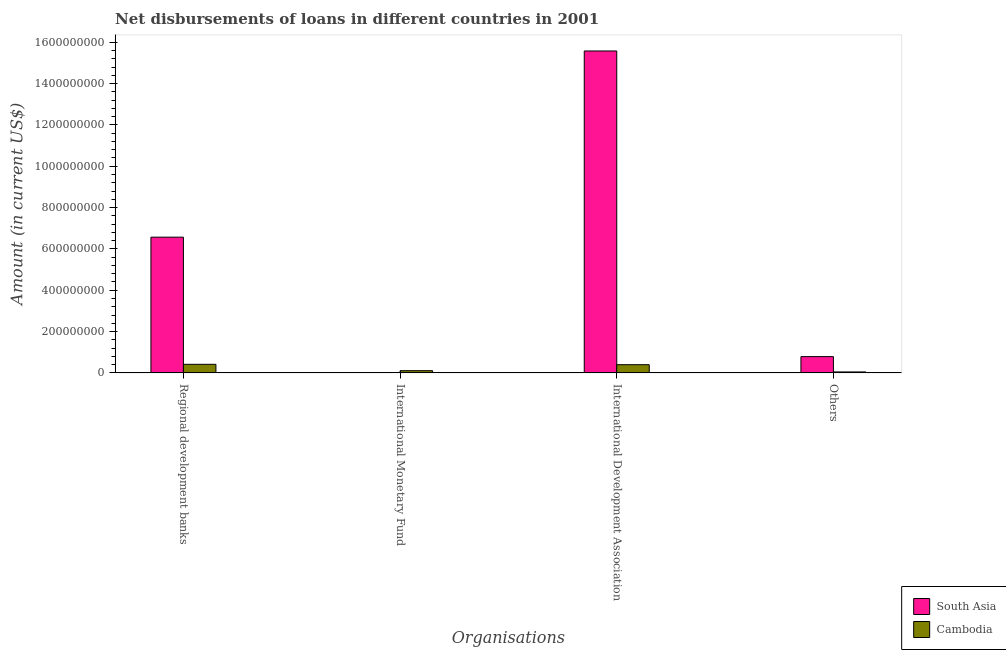Are the number of bars per tick equal to the number of legend labels?
Your response must be concise. No. How many bars are there on the 2nd tick from the right?
Provide a succinct answer. 2. What is the label of the 4th group of bars from the left?
Keep it short and to the point. Others. What is the amount of loan disimbursed by other organisations in Cambodia?
Your response must be concise. 4.50e+06. Across all countries, what is the maximum amount of loan disimbursed by international development association?
Offer a terse response. 1.56e+09. Across all countries, what is the minimum amount of loan disimbursed by other organisations?
Provide a succinct answer. 4.50e+06. What is the total amount of loan disimbursed by international development association in the graph?
Ensure brevity in your answer.  1.60e+09. What is the difference between the amount of loan disimbursed by other organisations in South Asia and that in Cambodia?
Your answer should be very brief. 7.42e+07. What is the difference between the amount of loan disimbursed by international monetary fund in Cambodia and the amount of loan disimbursed by other organisations in South Asia?
Your response must be concise. -6.81e+07. What is the average amount of loan disimbursed by international monetary fund per country?
Make the answer very short. 5.29e+06. What is the difference between the amount of loan disimbursed by regional development banks and amount of loan disimbursed by international development association in Cambodia?
Offer a terse response. 1.85e+06. What is the ratio of the amount of loan disimbursed by other organisations in Cambodia to that in South Asia?
Make the answer very short. 0.06. What is the difference between the highest and the second highest amount of loan disimbursed by other organisations?
Your response must be concise. 7.42e+07. What is the difference between the highest and the lowest amount of loan disimbursed by international development association?
Make the answer very short. 1.52e+09. Is the sum of the amount of loan disimbursed by other organisations in Cambodia and South Asia greater than the maximum amount of loan disimbursed by international monetary fund across all countries?
Offer a terse response. Yes. How many countries are there in the graph?
Offer a very short reply. 2. What is the difference between two consecutive major ticks on the Y-axis?
Make the answer very short. 2.00e+08. Does the graph contain any zero values?
Your response must be concise. Yes. Does the graph contain grids?
Provide a short and direct response. No. Where does the legend appear in the graph?
Ensure brevity in your answer.  Bottom right. How are the legend labels stacked?
Offer a terse response. Vertical. What is the title of the graph?
Offer a terse response. Net disbursements of loans in different countries in 2001. Does "Antigua and Barbuda" appear as one of the legend labels in the graph?
Your response must be concise. No. What is the label or title of the X-axis?
Give a very brief answer. Organisations. What is the label or title of the Y-axis?
Provide a short and direct response. Amount (in current US$). What is the Amount (in current US$) in South Asia in Regional development banks?
Your response must be concise. 6.57e+08. What is the Amount (in current US$) of Cambodia in Regional development banks?
Your response must be concise. 4.14e+07. What is the Amount (in current US$) in Cambodia in International Monetary Fund?
Your response must be concise. 1.06e+07. What is the Amount (in current US$) in South Asia in International Development Association?
Make the answer very short. 1.56e+09. What is the Amount (in current US$) of Cambodia in International Development Association?
Offer a terse response. 3.96e+07. What is the Amount (in current US$) of South Asia in Others?
Your answer should be very brief. 7.87e+07. What is the Amount (in current US$) in Cambodia in Others?
Offer a very short reply. 4.50e+06. Across all Organisations, what is the maximum Amount (in current US$) in South Asia?
Your response must be concise. 1.56e+09. Across all Organisations, what is the maximum Amount (in current US$) of Cambodia?
Give a very brief answer. 4.14e+07. Across all Organisations, what is the minimum Amount (in current US$) in South Asia?
Your answer should be compact. 0. Across all Organisations, what is the minimum Amount (in current US$) in Cambodia?
Give a very brief answer. 4.50e+06. What is the total Amount (in current US$) in South Asia in the graph?
Offer a terse response. 2.29e+09. What is the total Amount (in current US$) of Cambodia in the graph?
Provide a short and direct response. 9.60e+07. What is the difference between the Amount (in current US$) in Cambodia in Regional development banks and that in International Monetary Fund?
Provide a short and direct response. 3.08e+07. What is the difference between the Amount (in current US$) in South Asia in Regional development banks and that in International Development Association?
Your response must be concise. -9.01e+08. What is the difference between the Amount (in current US$) of Cambodia in Regional development banks and that in International Development Association?
Offer a very short reply. 1.85e+06. What is the difference between the Amount (in current US$) of South Asia in Regional development banks and that in Others?
Ensure brevity in your answer.  5.78e+08. What is the difference between the Amount (in current US$) in Cambodia in Regional development banks and that in Others?
Give a very brief answer. 3.69e+07. What is the difference between the Amount (in current US$) of Cambodia in International Monetary Fund and that in International Development Association?
Give a very brief answer. -2.90e+07. What is the difference between the Amount (in current US$) in Cambodia in International Monetary Fund and that in Others?
Offer a terse response. 6.08e+06. What is the difference between the Amount (in current US$) in South Asia in International Development Association and that in Others?
Ensure brevity in your answer.  1.48e+09. What is the difference between the Amount (in current US$) of Cambodia in International Development Association and that in Others?
Ensure brevity in your answer.  3.50e+07. What is the difference between the Amount (in current US$) in South Asia in Regional development banks and the Amount (in current US$) in Cambodia in International Monetary Fund?
Your answer should be compact. 6.46e+08. What is the difference between the Amount (in current US$) in South Asia in Regional development banks and the Amount (in current US$) in Cambodia in International Development Association?
Keep it short and to the point. 6.17e+08. What is the difference between the Amount (in current US$) of South Asia in Regional development banks and the Amount (in current US$) of Cambodia in Others?
Offer a terse response. 6.52e+08. What is the difference between the Amount (in current US$) in South Asia in International Development Association and the Amount (in current US$) in Cambodia in Others?
Your answer should be compact. 1.55e+09. What is the average Amount (in current US$) in South Asia per Organisations?
Offer a terse response. 5.73e+08. What is the average Amount (in current US$) in Cambodia per Organisations?
Provide a short and direct response. 2.40e+07. What is the difference between the Amount (in current US$) of South Asia and Amount (in current US$) of Cambodia in Regional development banks?
Make the answer very short. 6.15e+08. What is the difference between the Amount (in current US$) in South Asia and Amount (in current US$) in Cambodia in International Development Association?
Ensure brevity in your answer.  1.52e+09. What is the difference between the Amount (in current US$) of South Asia and Amount (in current US$) of Cambodia in Others?
Make the answer very short. 7.42e+07. What is the ratio of the Amount (in current US$) of Cambodia in Regional development banks to that in International Monetary Fund?
Your answer should be compact. 3.91. What is the ratio of the Amount (in current US$) in South Asia in Regional development banks to that in International Development Association?
Your response must be concise. 0.42. What is the ratio of the Amount (in current US$) in Cambodia in Regional development banks to that in International Development Association?
Offer a terse response. 1.05. What is the ratio of the Amount (in current US$) of South Asia in Regional development banks to that in Others?
Provide a short and direct response. 8.35. What is the ratio of the Amount (in current US$) of Cambodia in Regional development banks to that in Others?
Ensure brevity in your answer.  9.2. What is the ratio of the Amount (in current US$) of Cambodia in International Monetary Fund to that in International Development Association?
Provide a short and direct response. 0.27. What is the ratio of the Amount (in current US$) in Cambodia in International Monetary Fund to that in Others?
Provide a short and direct response. 2.35. What is the ratio of the Amount (in current US$) in South Asia in International Development Association to that in Others?
Give a very brief answer. 19.81. What is the ratio of the Amount (in current US$) of Cambodia in International Development Association to that in Others?
Your response must be concise. 8.79. What is the difference between the highest and the second highest Amount (in current US$) of South Asia?
Provide a succinct answer. 9.01e+08. What is the difference between the highest and the second highest Amount (in current US$) of Cambodia?
Offer a terse response. 1.85e+06. What is the difference between the highest and the lowest Amount (in current US$) in South Asia?
Your answer should be compact. 1.56e+09. What is the difference between the highest and the lowest Amount (in current US$) of Cambodia?
Your response must be concise. 3.69e+07. 